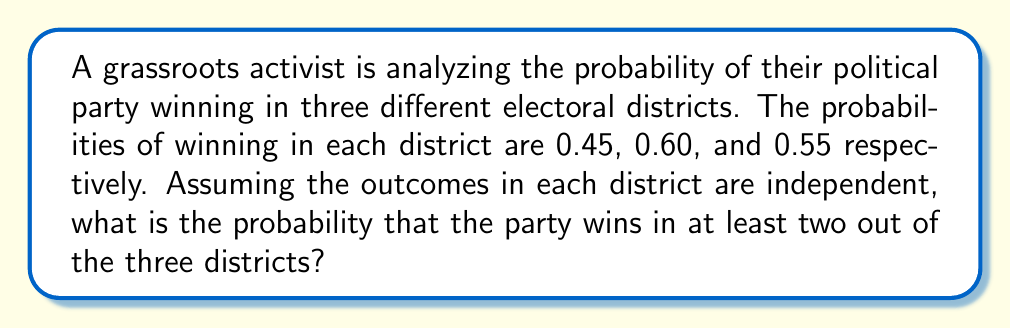Solve this math problem. To solve this problem, we need to use the concept of probability for multiple independent events. Let's approach this step-by-step:

1) First, let's define our events:
   $A$: Win in district 1 (probability = 0.45)
   $B$: Win in district 2 (probability = 0.60)
   $C$: Win in district 3 (probability = 0.55)

2) We need to find the probability of winning in at least two districts. This can happen in four ways:
   - Win in all three districts
   - Win in districts 1 and 2, lose in 3
   - Win in districts 1 and 3, lose in 2
   - Win in districts 2 and 3, lose in 1

3) Let's calculate each of these probabilities:

   P(Win all three) = $P(A) \times P(B) \times P(C)$ = $0.45 \times 0.60 \times 0.55$ = 0.1485

   P(Win 1 and 2, lose 3) = $P(A) \times P(B) \times (1-P(C))$ = $0.45 \times 0.60 \times 0.45$ = 0.1215

   P(Win 1 and 3, lose 2) = $P(A) \times (1-P(B)) \times P(C)$ = $0.45 \times 0.40 \times 0.55$ = 0.0990

   P(Win 2 and 3, lose 1) = $(1-P(A)) \times P(B) \times P(C)$ = $0.55 \times 0.60 \times 0.55$ = 0.1815

4) The total probability is the sum of these individual probabilities:

   $P(\text{at least two}) = 0.1485 + 0.1215 + 0.0990 + 0.1815 = 0.5505$

Therefore, the probability of winning in at least two out of the three districts is 0.5505 or 55.05%.
Answer: 0.5505 or 55.05% 